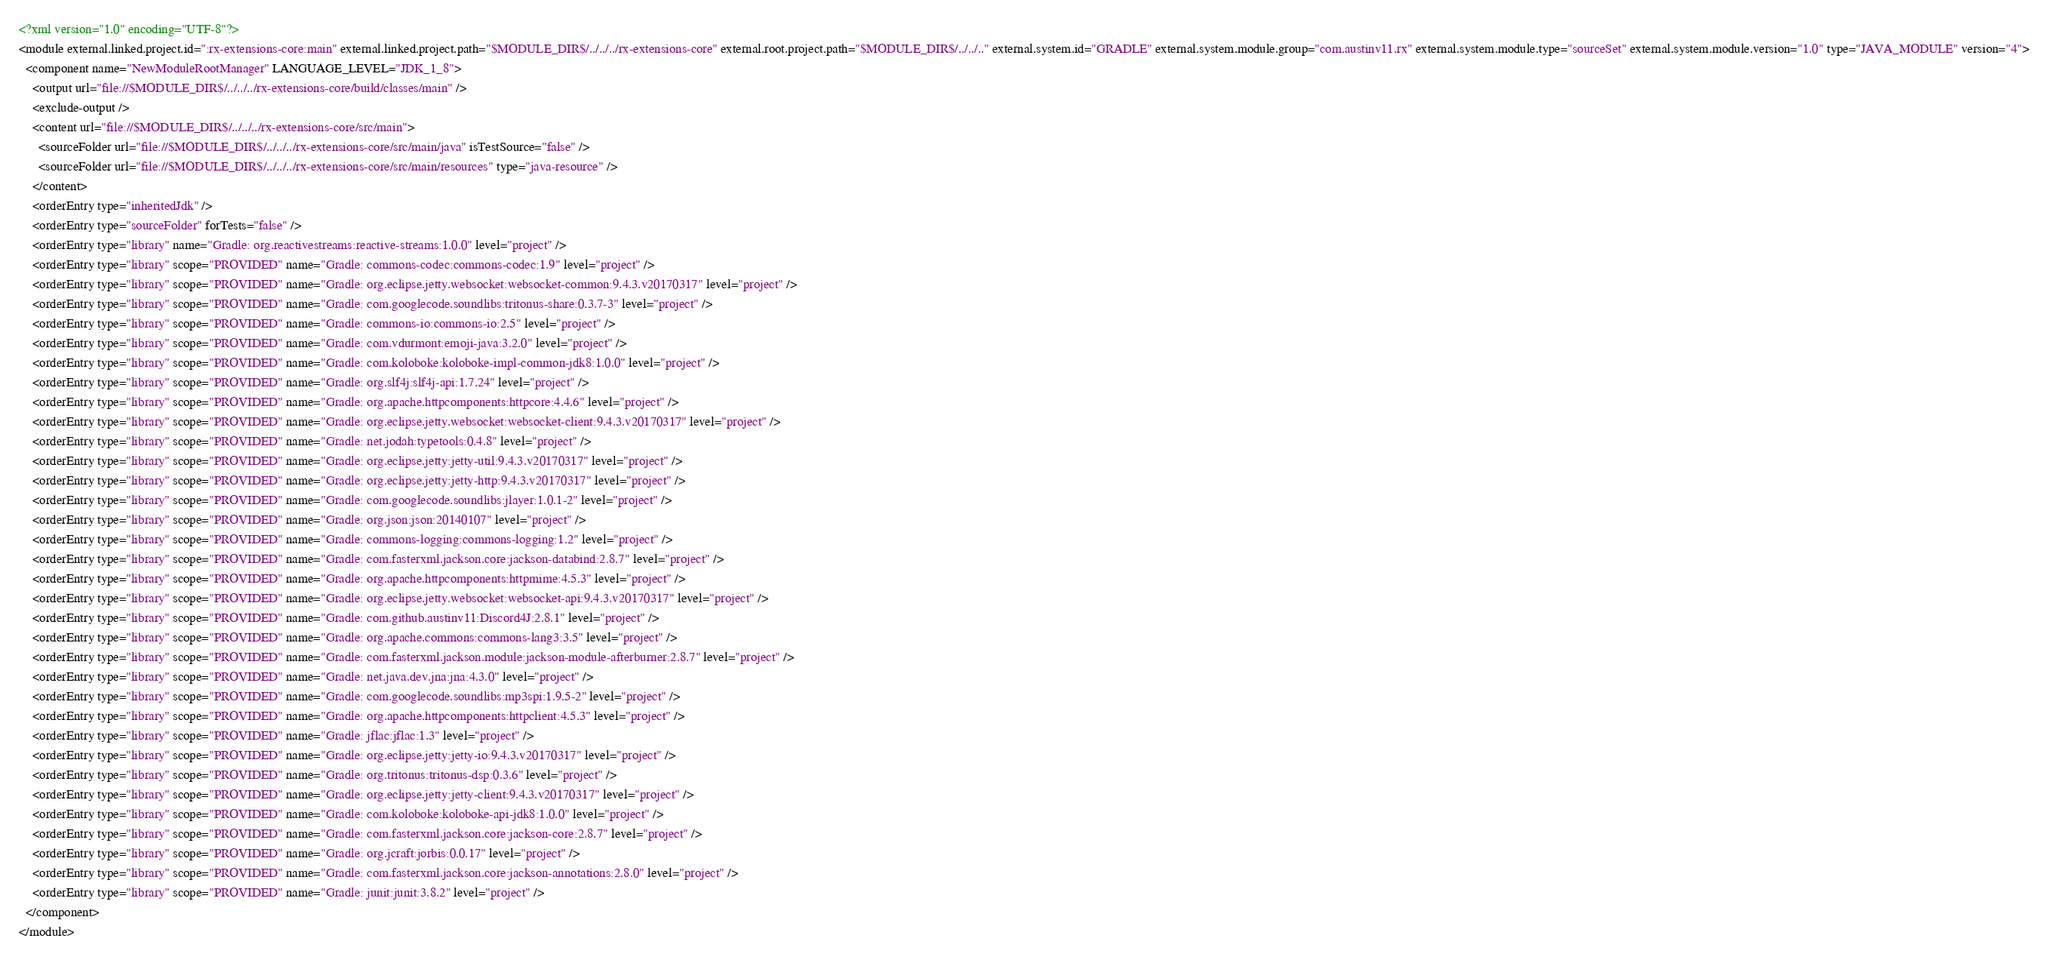<code> <loc_0><loc_0><loc_500><loc_500><_XML_><?xml version="1.0" encoding="UTF-8"?>
<module external.linked.project.id=":rx-extensions-core:main" external.linked.project.path="$MODULE_DIR$/../../../rx-extensions-core" external.root.project.path="$MODULE_DIR$/../../.." external.system.id="GRADLE" external.system.module.group="com.austinv11.rx" external.system.module.type="sourceSet" external.system.module.version="1.0" type="JAVA_MODULE" version="4">
  <component name="NewModuleRootManager" LANGUAGE_LEVEL="JDK_1_8">
    <output url="file://$MODULE_DIR$/../../../rx-extensions-core/build/classes/main" />
    <exclude-output />
    <content url="file://$MODULE_DIR$/../../../rx-extensions-core/src/main">
      <sourceFolder url="file://$MODULE_DIR$/../../../rx-extensions-core/src/main/java" isTestSource="false" />
      <sourceFolder url="file://$MODULE_DIR$/../../../rx-extensions-core/src/main/resources" type="java-resource" />
    </content>
    <orderEntry type="inheritedJdk" />
    <orderEntry type="sourceFolder" forTests="false" />
    <orderEntry type="library" name="Gradle: org.reactivestreams:reactive-streams:1.0.0" level="project" />
    <orderEntry type="library" scope="PROVIDED" name="Gradle: commons-codec:commons-codec:1.9" level="project" />
    <orderEntry type="library" scope="PROVIDED" name="Gradle: org.eclipse.jetty.websocket:websocket-common:9.4.3.v20170317" level="project" />
    <orderEntry type="library" scope="PROVIDED" name="Gradle: com.googlecode.soundlibs:tritonus-share:0.3.7-3" level="project" />
    <orderEntry type="library" scope="PROVIDED" name="Gradle: commons-io:commons-io:2.5" level="project" />
    <orderEntry type="library" scope="PROVIDED" name="Gradle: com.vdurmont:emoji-java:3.2.0" level="project" />
    <orderEntry type="library" scope="PROVIDED" name="Gradle: com.koloboke:koloboke-impl-common-jdk8:1.0.0" level="project" />
    <orderEntry type="library" scope="PROVIDED" name="Gradle: org.slf4j:slf4j-api:1.7.24" level="project" />
    <orderEntry type="library" scope="PROVIDED" name="Gradle: org.apache.httpcomponents:httpcore:4.4.6" level="project" />
    <orderEntry type="library" scope="PROVIDED" name="Gradle: org.eclipse.jetty.websocket:websocket-client:9.4.3.v20170317" level="project" />
    <orderEntry type="library" scope="PROVIDED" name="Gradle: net.jodah:typetools:0.4.8" level="project" />
    <orderEntry type="library" scope="PROVIDED" name="Gradle: org.eclipse.jetty:jetty-util:9.4.3.v20170317" level="project" />
    <orderEntry type="library" scope="PROVIDED" name="Gradle: org.eclipse.jetty:jetty-http:9.4.3.v20170317" level="project" />
    <orderEntry type="library" scope="PROVIDED" name="Gradle: com.googlecode.soundlibs:jlayer:1.0.1-2" level="project" />
    <orderEntry type="library" scope="PROVIDED" name="Gradle: org.json:json:20140107" level="project" />
    <orderEntry type="library" scope="PROVIDED" name="Gradle: commons-logging:commons-logging:1.2" level="project" />
    <orderEntry type="library" scope="PROVIDED" name="Gradle: com.fasterxml.jackson.core:jackson-databind:2.8.7" level="project" />
    <orderEntry type="library" scope="PROVIDED" name="Gradle: org.apache.httpcomponents:httpmime:4.5.3" level="project" />
    <orderEntry type="library" scope="PROVIDED" name="Gradle: org.eclipse.jetty.websocket:websocket-api:9.4.3.v20170317" level="project" />
    <orderEntry type="library" scope="PROVIDED" name="Gradle: com.github.austinv11:Discord4J:2.8.1" level="project" />
    <orderEntry type="library" scope="PROVIDED" name="Gradle: org.apache.commons:commons-lang3:3.5" level="project" />
    <orderEntry type="library" scope="PROVIDED" name="Gradle: com.fasterxml.jackson.module:jackson-module-afterburner:2.8.7" level="project" />
    <orderEntry type="library" scope="PROVIDED" name="Gradle: net.java.dev.jna:jna:4.3.0" level="project" />
    <orderEntry type="library" scope="PROVIDED" name="Gradle: com.googlecode.soundlibs:mp3spi:1.9.5-2" level="project" />
    <orderEntry type="library" scope="PROVIDED" name="Gradle: org.apache.httpcomponents:httpclient:4.5.3" level="project" />
    <orderEntry type="library" scope="PROVIDED" name="Gradle: jflac:jflac:1.3" level="project" />
    <orderEntry type="library" scope="PROVIDED" name="Gradle: org.eclipse.jetty:jetty-io:9.4.3.v20170317" level="project" />
    <orderEntry type="library" scope="PROVIDED" name="Gradle: org.tritonus:tritonus-dsp:0.3.6" level="project" />
    <orderEntry type="library" scope="PROVIDED" name="Gradle: org.eclipse.jetty:jetty-client:9.4.3.v20170317" level="project" />
    <orderEntry type="library" scope="PROVIDED" name="Gradle: com.koloboke:koloboke-api-jdk8:1.0.0" level="project" />
    <orderEntry type="library" scope="PROVIDED" name="Gradle: com.fasterxml.jackson.core:jackson-core:2.8.7" level="project" />
    <orderEntry type="library" scope="PROVIDED" name="Gradle: org.jcraft:jorbis:0.0.17" level="project" />
    <orderEntry type="library" scope="PROVIDED" name="Gradle: com.fasterxml.jackson.core:jackson-annotations:2.8.0" level="project" />
    <orderEntry type="library" scope="PROVIDED" name="Gradle: junit:junit:3.8.2" level="project" />
  </component>
</module></code> 